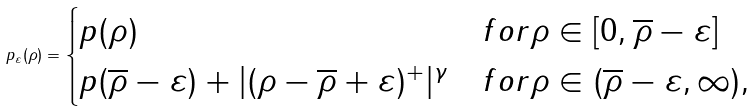<formula> <loc_0><loc_0><loc_500><loc_500>p _ { \varepsilon } ( \rho ) = \begin{cases} p ( \rho ) & f o r \rho \in [ 0 , \overline { \rho } - \varepsilon ] \\ p ( \overline { \rho } - \varepsilon ) + | ( \rho - \overline { \rho } + \varepsilon ) ^ { + } | ^ { \gamma } & f o r \rho \in ( \overline { \rho } - \varepsilon , \infty ) , \end{cases}</formula> 